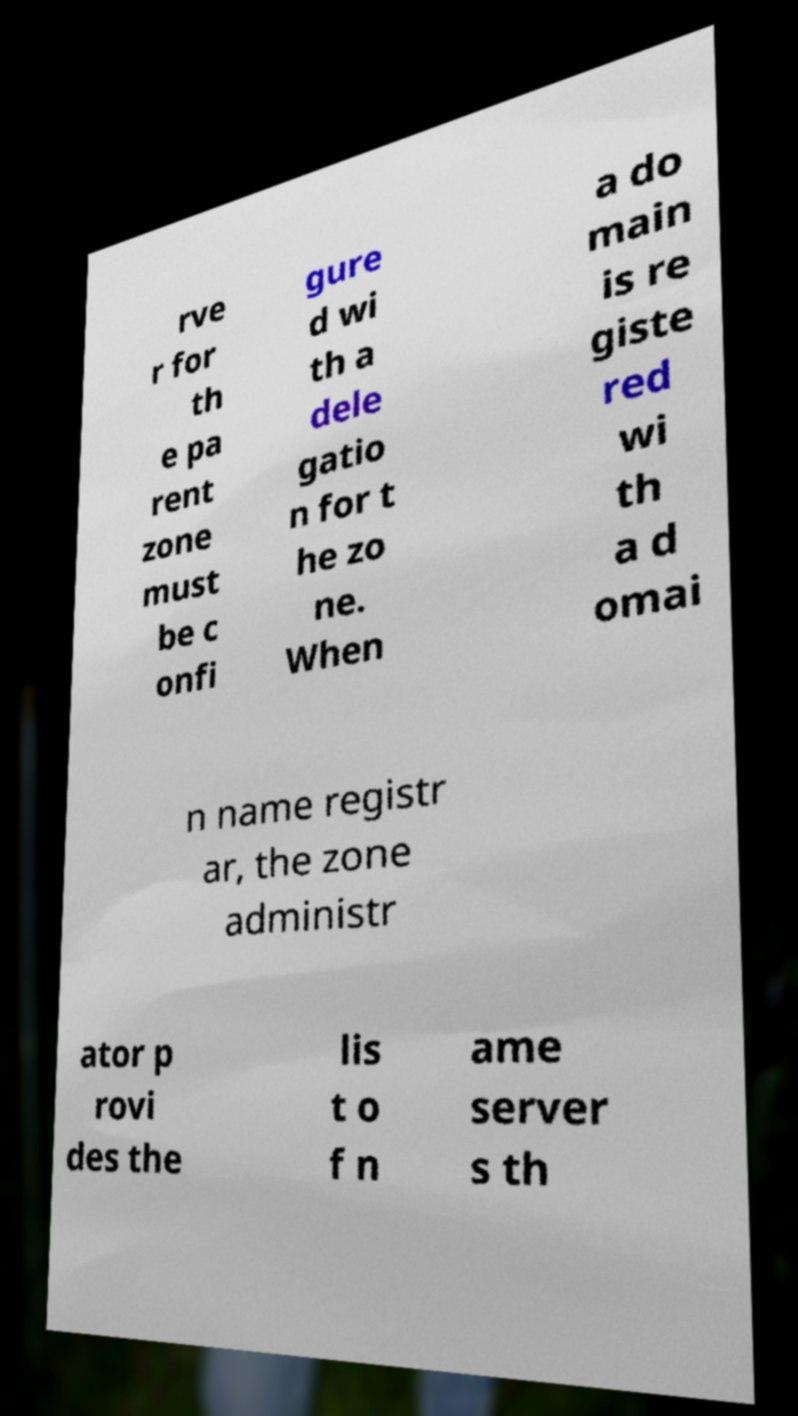Can you read and provide the text displayed in the image?This photo seems to have some interesting text. Can you extract and type it out for me? rve r for th e pa rent zone must be c onfi gure d wi th a dele gatio n for t he zo ne. When a do main is re giste red wi th a d omai n name registr ar, the zone administr ator p rovi des the lis t o f n ame server s th 